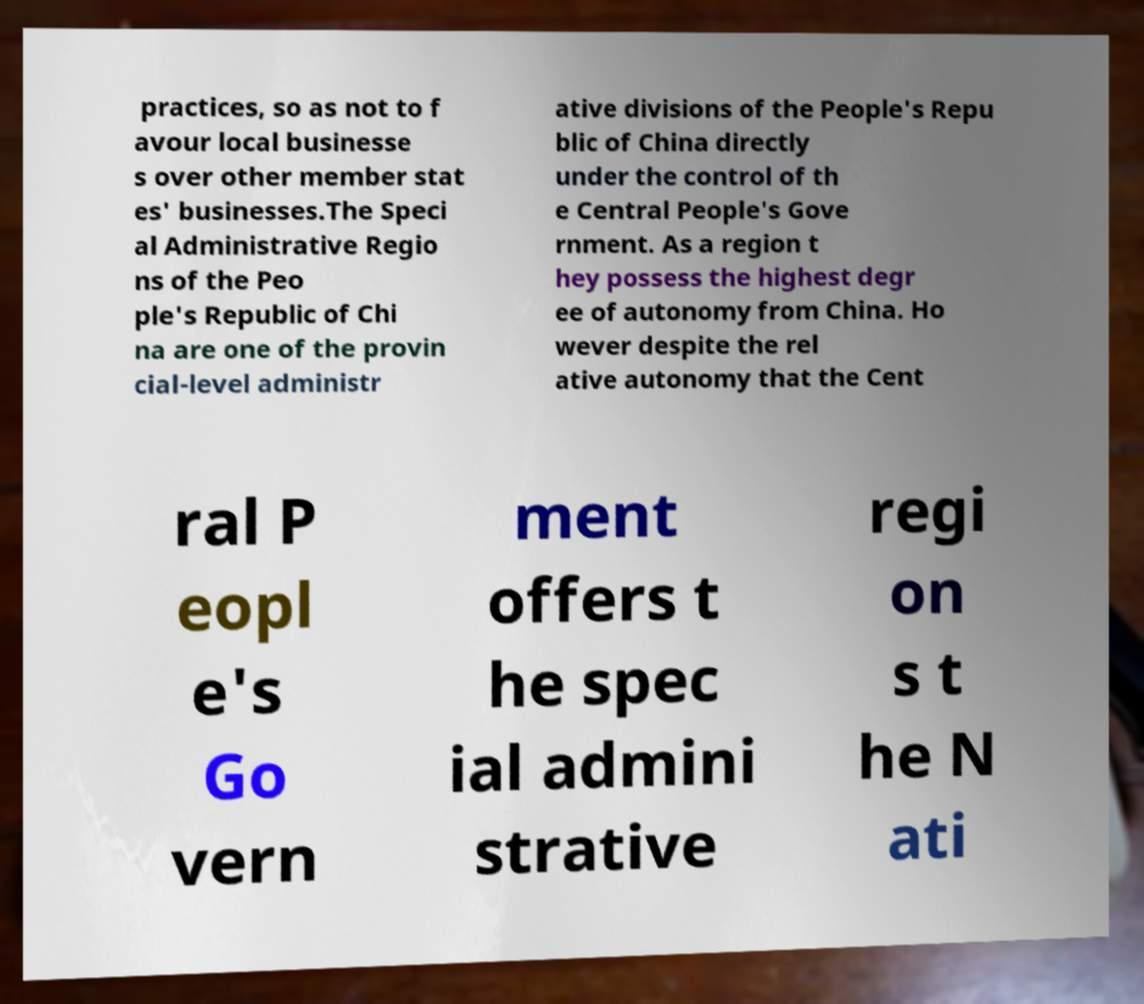Please identify and transcribe the text found in this image. practices, so as not to f avour local businesse s over other member stat es' businesses.The Speci al Administrative Regio ns of the Peo ple's Republic of Chi na are one of the provin cial-level administr ative divisions of the People's Repu blic of China directly under the control of th e Central People's Gove rnment. As a region t hey possess the highest degr ee of autonomy from China. Ho wever despite the rel ative autonomy that the Cent ral P eopl e's Go vern ment offers t he spec ial admini strative regi on s t he N ati 